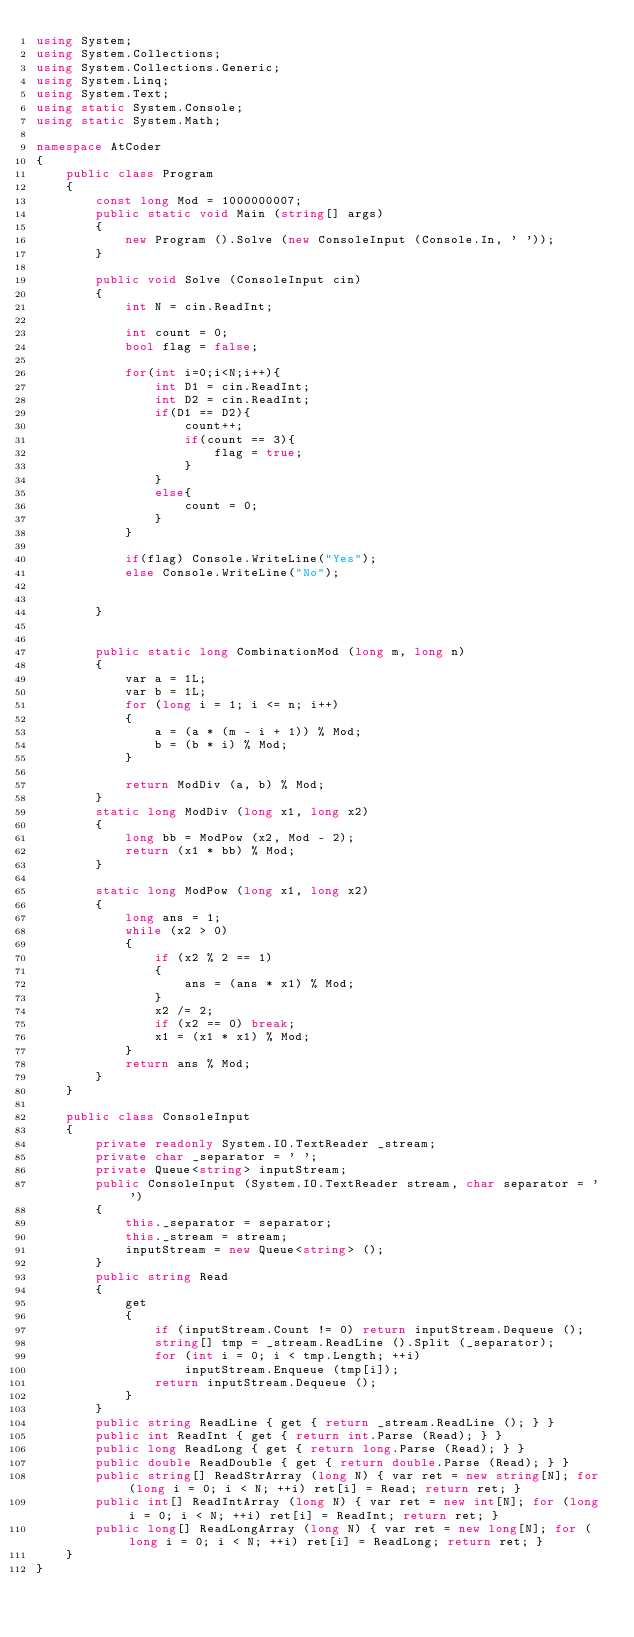Convert code to text. <code><loc_0><loc_0><loc_500><loc_500><_C#_>using System;
using System.Collections;
using System.Collections.Generic;
using System.Linq;
using System.Text;
using static System.Console;
using static System.Math;

namespace AtCoder
{
    public class Program
    {
        const long Mod = 1000000007;
        public static void Main (string[] args)
        {
            new Program ().Solve (new ConsoleInput (Console.In, ' '));
        }

        public void Solve (ConsoleInput cin)
        {
            int N = cin.ReadInt;

            int count = 0;
            bool flag = false;

            for(int i=0;i<N;i++){
                int D1 = cin.ReadInt;
                int D2 = cin.ReadInt;
                if(D1 == D2){
                    count++;
                    if(count == 3){
                        flag = true;
                    }
                }
                else{
                    count = 0;
                }
            }

            if(flag) Console.WriteLine("Yes");
            else Console.WriteLine("No");                  
                
            
        }


        public static long CombinationMod (long m, long n)
        {
            var a = 1L;
            var b = 1L;
            for (long i = 1; i <= n; i++)
            {
                a = (a * (m - i + 1)) % Mod;
                b = (b * i) % Mod;
            }

            return ModDiv (a, b) % Mod;
        }
        static long ModDiv (long x1, long x2)
        {
            long bb = ModPow (x2, Mod - 2);
            return (x1 * bb) % Mod;
        }

        static long ModPow (long x1, long x2)
        {
            long ans = 1;
            while (x2 > 0)
            {
                if (x2 % 2 == 1)
                {
                    ans = (ans * x1) % Mod;
                }
                x2 /= 2;
                if (x2 == 0) break;
                x1 = (x1 * x1) % Mod;
            }
            return ans % Mod;
        }
    }

    public class ConsoleInput
    {
        private readonly System.IO.TextReader _stream;
        private char _separator = ' ';
        private Queue<string> inputStream;
        public ConsoleInput (System.IO.TextReader stream, char separator = ' ')
        {
            this._separator = separator;
            this._stream = stream;
            inputStream = new Queue<string> ();
        }
        public string Read
        {
            get
            {
                if (inputStream.Count != 0) return inputStream.Dequeue ();
                string[] tmp = _stream.ReadLine ().Split (_separator);
                for (int i = 0; i < tmp.Length; ++i)
                    inputStream.Enqueue (tmp[i]);
                return inputStream.Dequeue ();
            }
        }
        public string ReadLine { get { return _stream.ReadLine (); } }
        public int ReadInt { get { return int.Parse (Read); } }
        public long ReadLong { get { return long.Parse (Read); } }
        public double ReadDouble { get { return double.Parse (Read); } }
        public string[] ReadStrArray (long N) { var ret = new string[N]; for (long i = 0; i < N; ++i) ret[i] = Read; return ret; }
        public int[] ReadIntArray (long N) { var ret = new int[N]; for (long i = 0; i < N; ++i) ret[i] = ReadInt; return ret; }
        public long[] ReadLongArray (long N) { var ret = new long[N]; for (long i = 0; i < N; ++i) ret[i] = ReadLong; return ret; }
    }
}</code> 